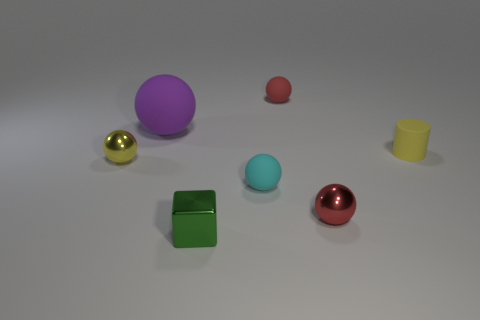Subtract all gray blocks. How many red balls are left? 2 Subtract all purple spheres. How many spheres are left? 4 Subtract all small red spheres. How many spheres are left? 3 Add 2 metal balls. How many objects exist? 9 Subtract 1 balls. How many balls are left? 4 Subtract all cylinders. How many objects are left? 6 Subtract all big purple objects. Subtract all metal blocks. How many objects are left? 5 Add 4 tiny cylinders. How many tiny cylinders are left? 5 Add 6 cyan things. How many cyan things exist? 7 Subtract 1 yellow cylinders. How many objects are left? 6 